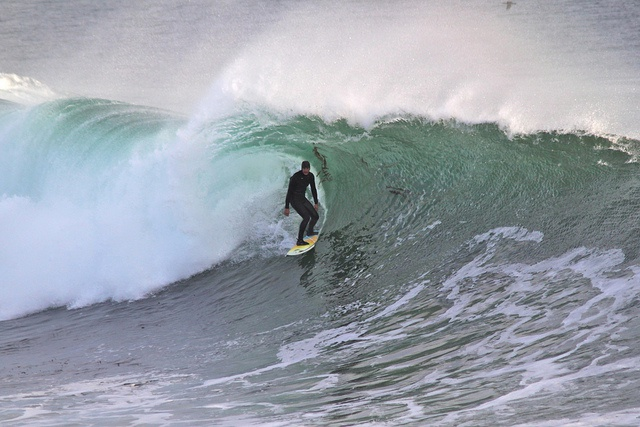Describe the objects in this image and their specific colors. I can see people in darkgray, black, and gray tones, surfboard in darkgray, gray, tan, and lightgray tones, and bird in darkgray and gray tones in this image. 